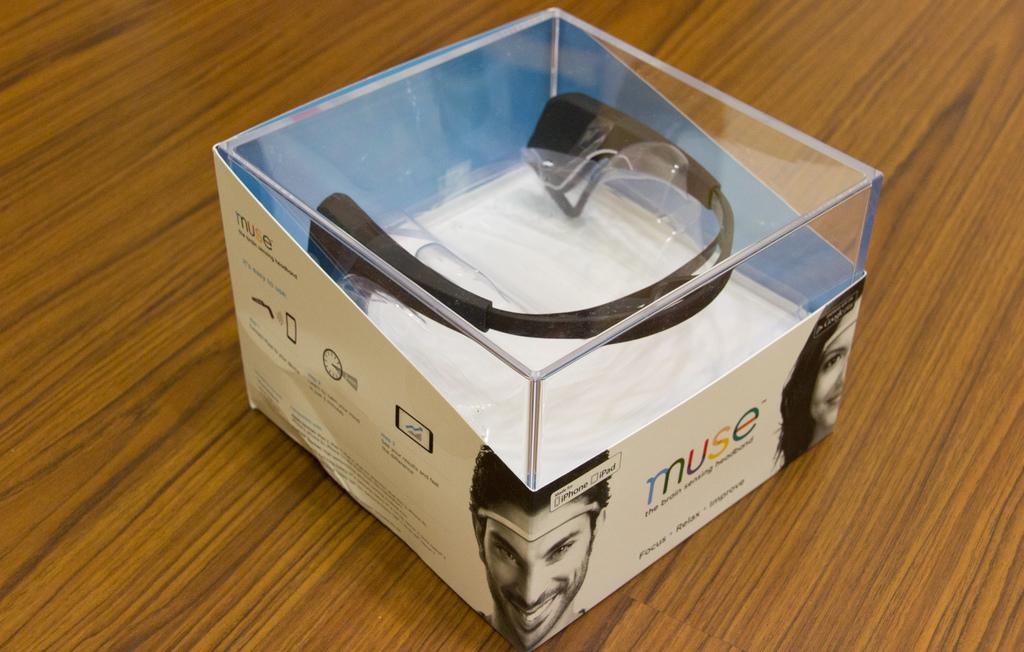What is the main subject in the center of the image? There is an object in the center of the image. How is the object positioned in the image? The object is packed on the wall. What type of roll can be seen bouncing off the object in the image? There is no roll or bouncing object present in the image; it only features an object packed on the wall. 